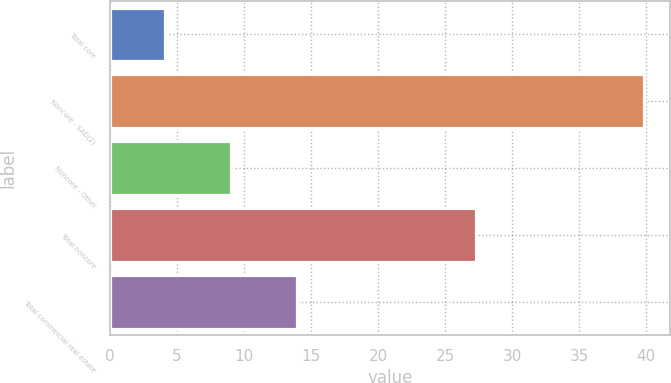<chart> <loc_0><loc_0><loc_500><loc_500><bar_chart><fcel>Total core<fcel>Noncore - SAD(2)<fcel>Noncore - Other<fcel>Total noncore<fcel>Total commercial real estate<nl><fcel>4.08<fcel>39.8<fcel>9.06<fcel>27.33<fcel>13.96<nl></chart> 